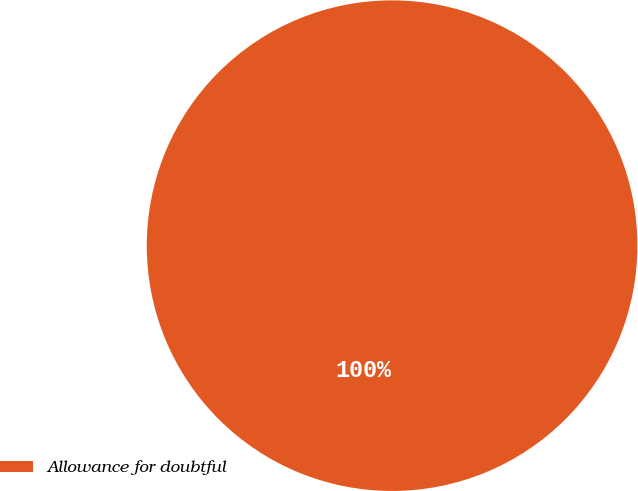<chart> <loc_0><loc_0><loc_500><loc_500><pie_chart><fcel>Allowance for doubtful<nl><fcel>100.0%<nl></chart> 